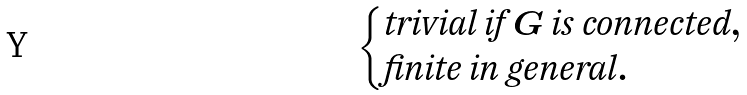<formula> <loc_0><loc_0><loc_500><loc_500>\begin{cases} \text {trivial if } G \text { is connected} , \\ \text {finite in general} . \end{cases}</formula> 